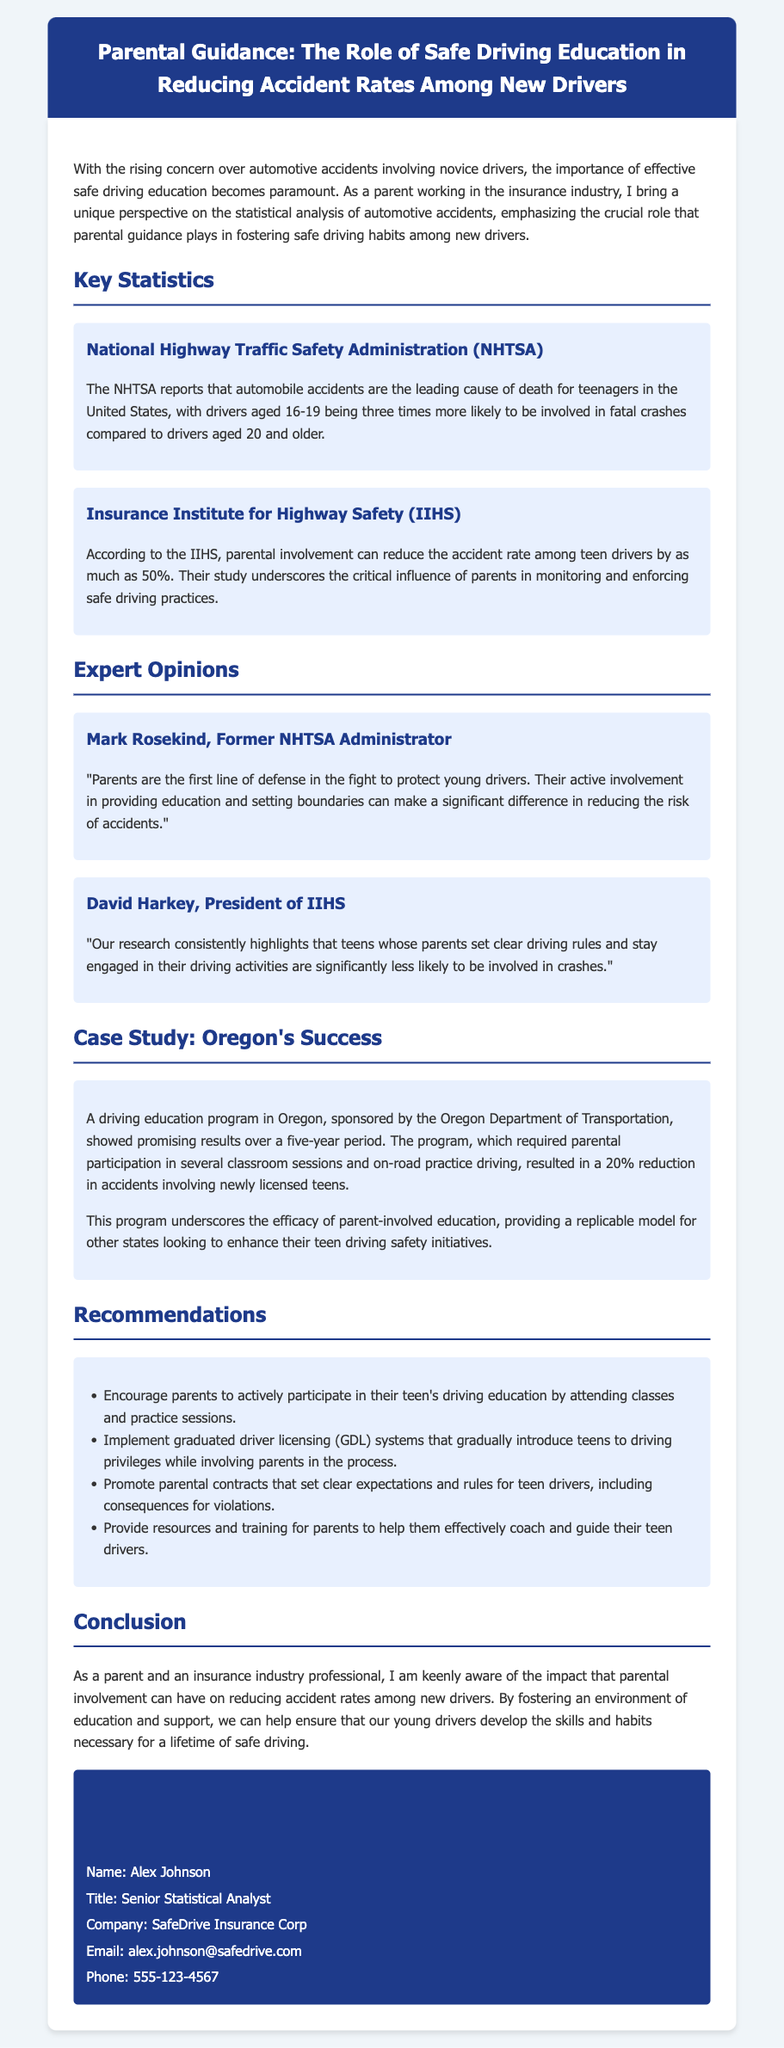What is the leading cause of death for teenagers in the United States? The document states that automobile accidents are the leading cause of death for teenagers in the United States.
Answer: Automobile accidents What is the percentage reduction in accident rates due to parental involvement? According to the IIHS, parental involvement can reduce the accident rate among teen drivers by as much as 50%.
Answer: 50% Who is the former NHTSA Administrator quoted in the document? The document mentions Mark Rosekind as the former NHTSA Administrator.
Answer: Mark Rosekind What was the percentage reduction in accidents involving newly licensed teens in Oregon's driving education program? The case study highlights a 20% reduction in accidents during the program in Oregon.
Answer: 20% What organization sponsored the driving education program in Oregon? The document specifies that the Oregon Department of Transportation sponsored the program.
Answer: Oregon Department of Transportation What type of educational involvement is encouraged for parents? The document suggests that parents should actively participate in their teen's driving education by attending classes and practice sessions.
Answer: Actively participate What position does David Harkey hold? The document indicates that David Harkey is the President of IIHS.
Answer: President of IIHS How many years did the Oregon driving education program run? The case study states that the program showed results over a five-year period.
Answer: Five years What is the title of Alex Johnson? The contact information section identifies Alex Johnson's title as Senior Statistical Analyst.
Answer: Senior Statistical Analyst 